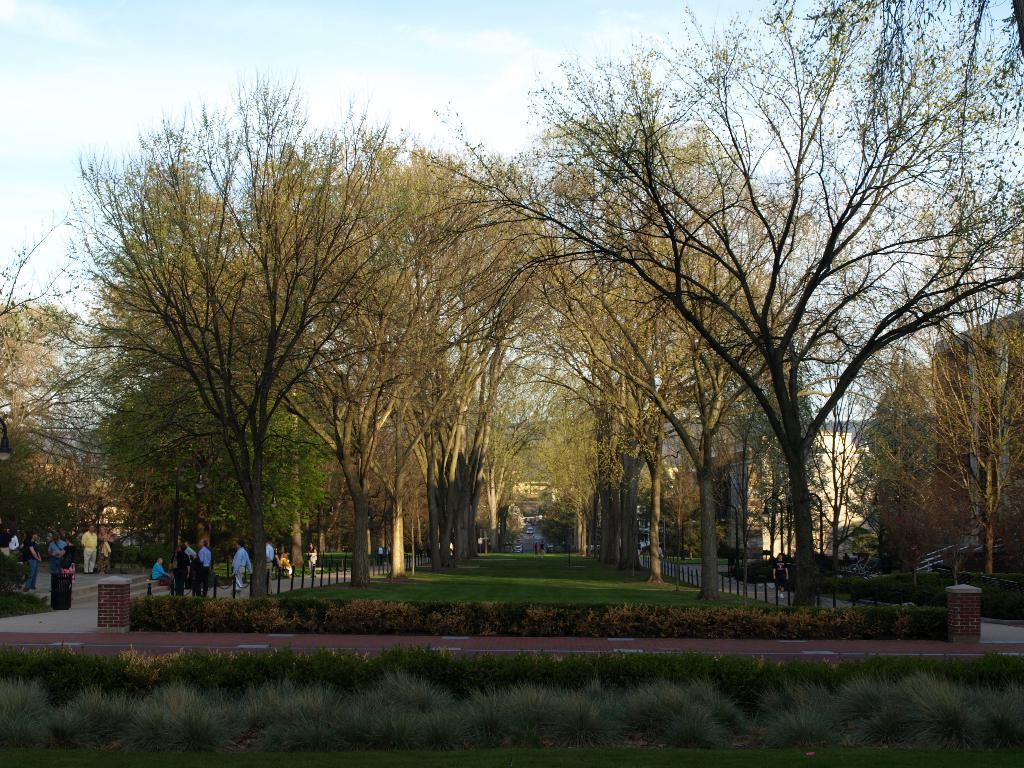What type of vegetation is at the bottom of the image? There are plants at the bottom of the image. What can be seen in the middle of the image? There is a group of people and trees in the middle of the image. What is visible at the top of the image? The sky is visible at the top of the image. How would you describe the sky in the image? The sky appears to be cloudy. What type of mask is being worn by the lead person in the image? There is no mention of a mask or a lead person in the image; it features plants, a group of people, trees, and a cloudy sky. 